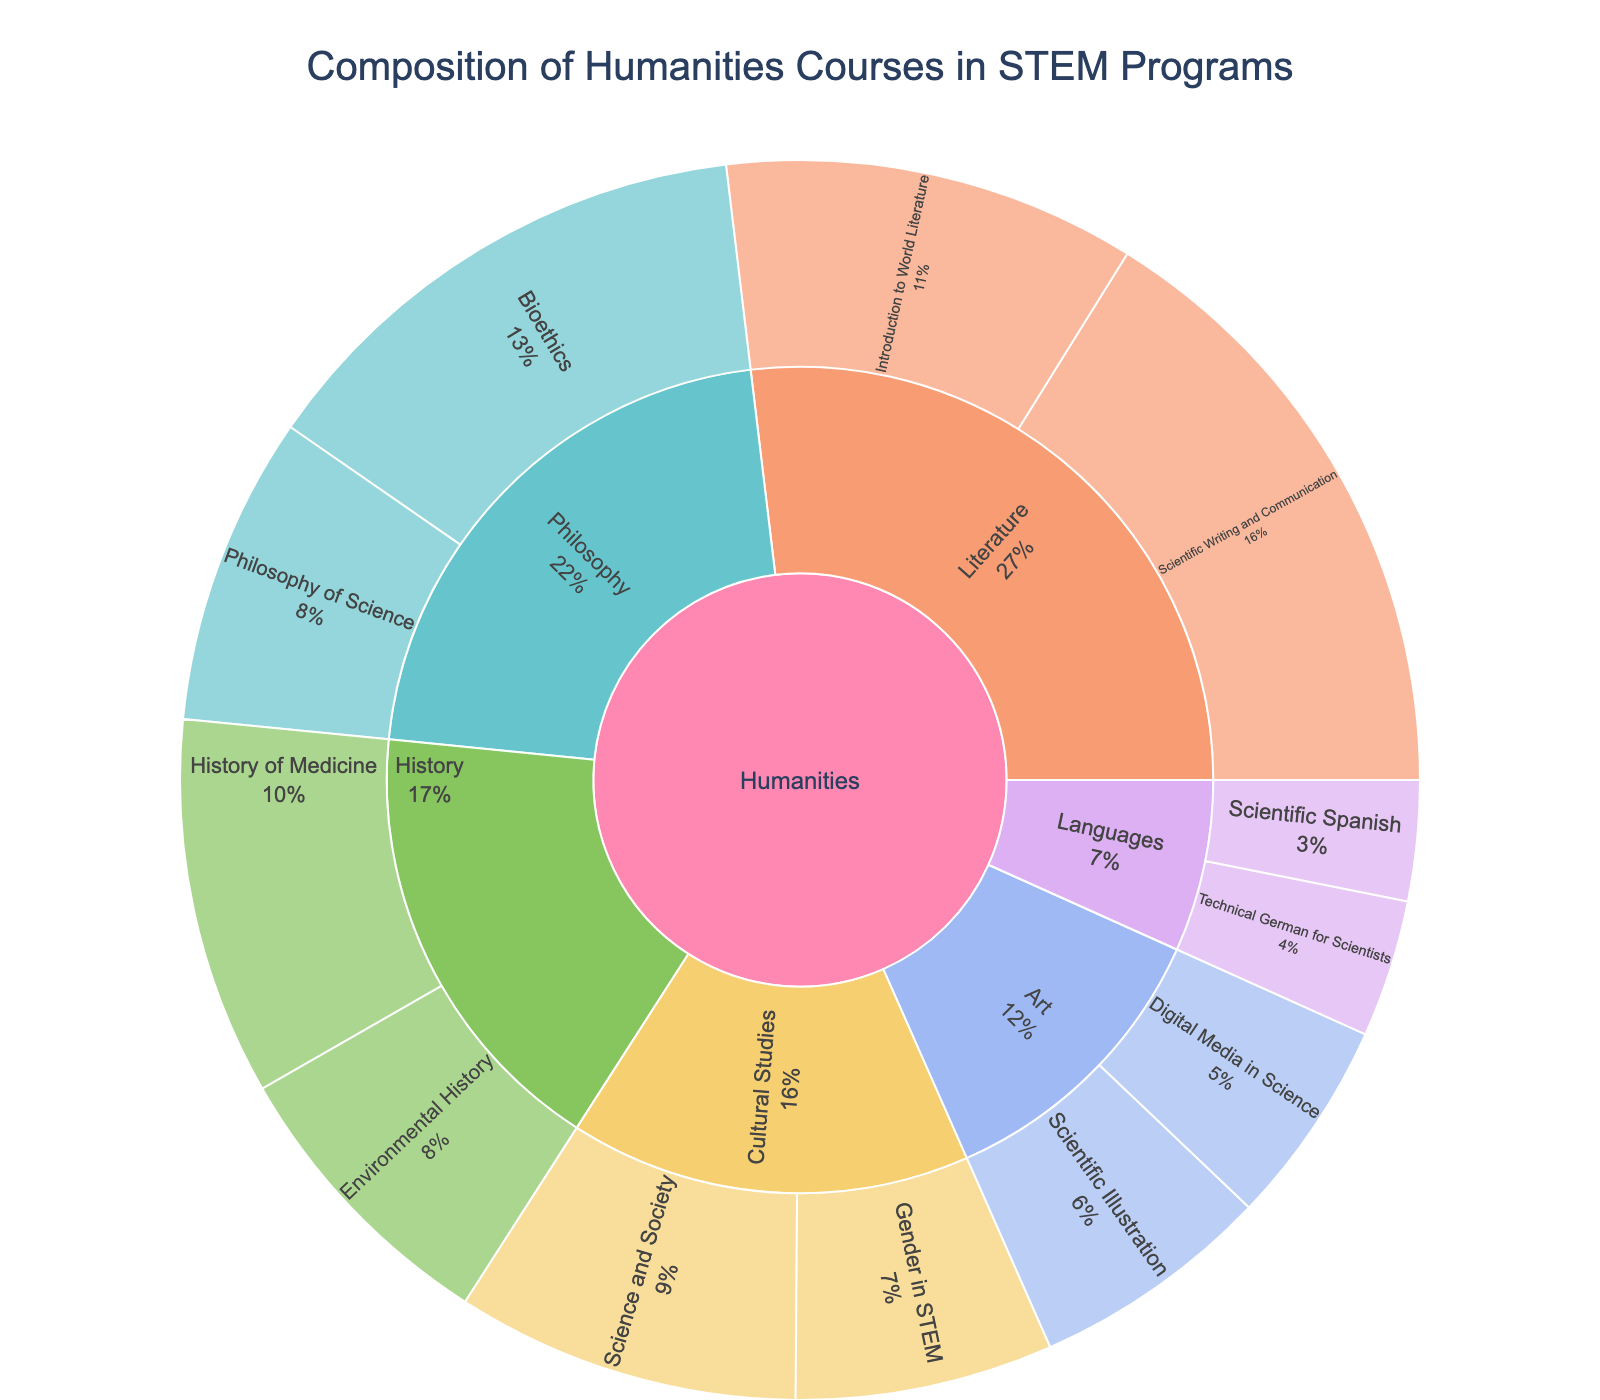What's the title of the Sunburst Plot? The title of a plot is generally located at the top of the figure. In this case, the title appears as "Composition of Humanities Courses in STEM Programs".
Answer: Composition of Humanities Courses in STEM Programs Which subcategory has the course with the highest enrollment? Look at the different subcategories (Literature, Philosophy, History, Art, Languages, Cultural Studies) and identify the course with the highest enrollment. The subcategory with the highest enrolled course is Literature with "Scientific Writing and Communication" having 180 enrollments.
Answer: Literature How many courses fall under the subcategory of Cultural Studies? In the Cultural Studies subcategory, there are two courses: "Science and Society" and "Gender in STEM". Simply count these courses.
Answer: 2 What is the combined enrollment for all Philosophy courses? There are two courses under Philosophy: "Bioethics" and "Philosophy of Science". Add their enrollment numbers: 150 + 90.
Answer: 240 Which course under Art has fewer enrollments? Within the Art subcategory, there are two courses: "Scientific Illustration" with 70 enrollments and "Digital Media in Science" with 60 enrollments. The course with fewer enrollments is "Digital Media in Science".
Answer: Digital Media in Science What percentage of the total enrollment does the course "Introduction to World Literature" have? Total all enrollments: 120 + 180 + 150 + 90 + 110 + 85 + 70 + 60 + 40 + 35 + 100 + 75 = 1115. To find the percentage: (120 / 1115) * 100 ≈ 10.8%.
Answer: 10.8% Compare the enrollments between "Technical German for Scientists" and "Scientific Spanish". Which has more enrollments and by how much? "Technical German for Scientists" has 40 enrollments while "Scientific Spanish" has 35. The difference is 40 - 35.
Answer: Technical German for Scientists, by 5 What is the total enrollment for courses in the subcategory History? Identify the courses within History: "History of Medicine" and "Environmental History". Add their enrollments: 110 + 85.
Answer: 195 Which subcategory has the least combined enrollment? Calculate the total enrollment for each subcategory: 
- Literature: 120 + 180 = 300
- Philosophy: 150 + 90 = 240
- History: 110 + 85 = 195
- Art: 70 + 60 = 130
- Languages: 40 + 35 = 75
- Cultural Studies: 100 + 75 = 175
The subcategory with the least combined enrollment is Languages with a total of 75 enrollments.
Answer: Languages 